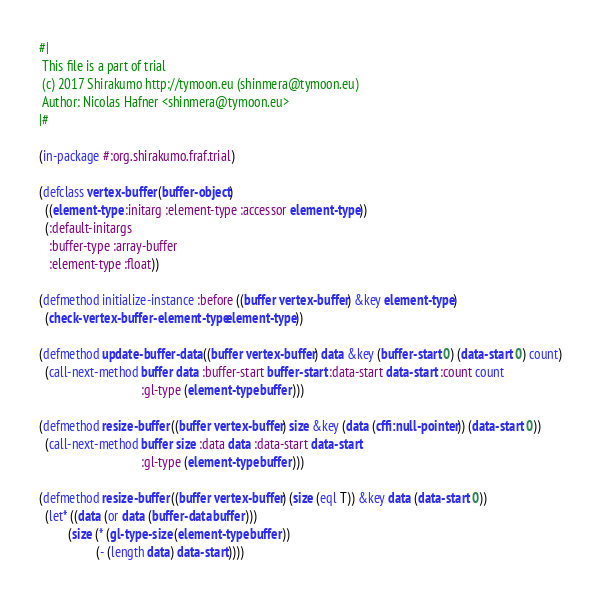Convert code to text. <code><loc_0><loc_0><loc_500><loc_500><_Lisp_>#|
 This file is a part of trial
 (c) 2017 Shirakumo http://tymoon.eu (shinmera@tymoon.eu)
 Author: Nicolas Hafner <shinmera@tymoon.eu>
|#

(in-package #:org.shirakumo.fraf.trial)

(defclass vertex-buffer (buffer-object)
  ((element-type :initarg :element-type :accessor element-type))
  (:default-initargs
   :buffer-type :array-buffer
   :element-type :float))

(defmethod initialize-instance :before ((buffer vertex-buffer) &key element-type)
  (check-vertex-buffer-element-type element-type))

(defmethod update-buffer-data ((buffer vertex-buffer) data &key (buffer-start 0) (data-start 0) count)
  (call-next-method buffer data :buffer-start buffer-start :data-start data-start :count count
                                :gl-type (element-type buffer)))

(defmethod resize-buffer ((buffer vertex-buffer) size &key (data (cffi:null-pointer)) (data-start 0))
  (call-next-method buffer size :data data :data-start data-start
                                :gl-type (element-type buffer)))

(defmethod resize-buffer ((buffer vertex-buffer) (size (eql T)) &key data (data-start 0))
  (let* ((data (or data (buffer-data buffer)))
         (size (* (gl-type-size (element-type buffer))
                  (- (length data) data-start))))</code> 